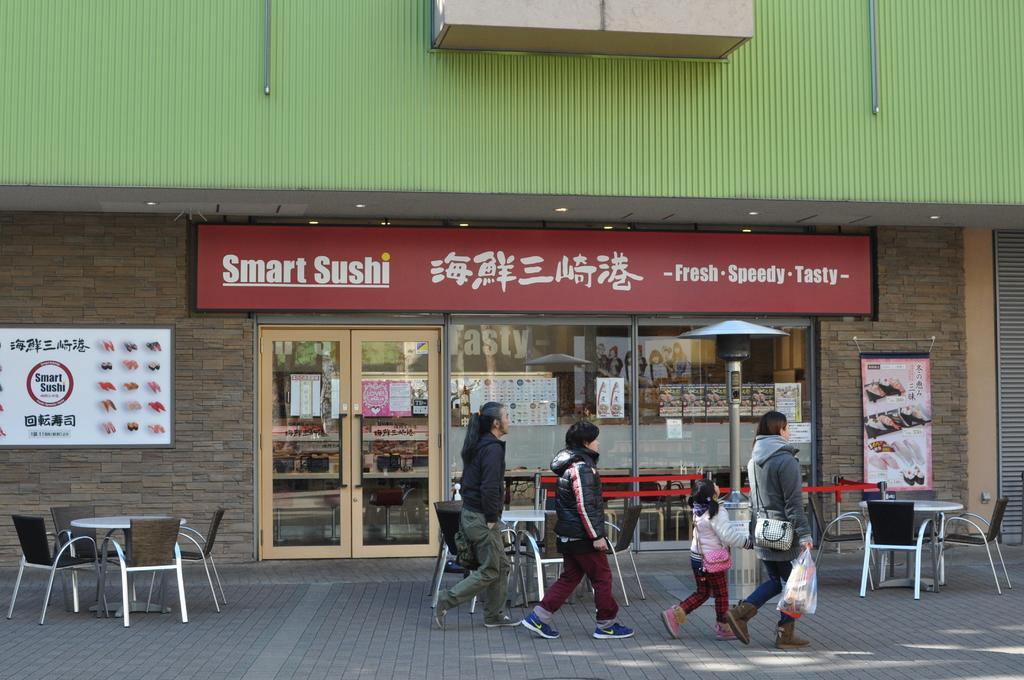Can you describe this image briefly? In this image I see 3 persons and a child who are on the path and there are tables and chairs in the background and I see a shop and on the wall I see the boards. 